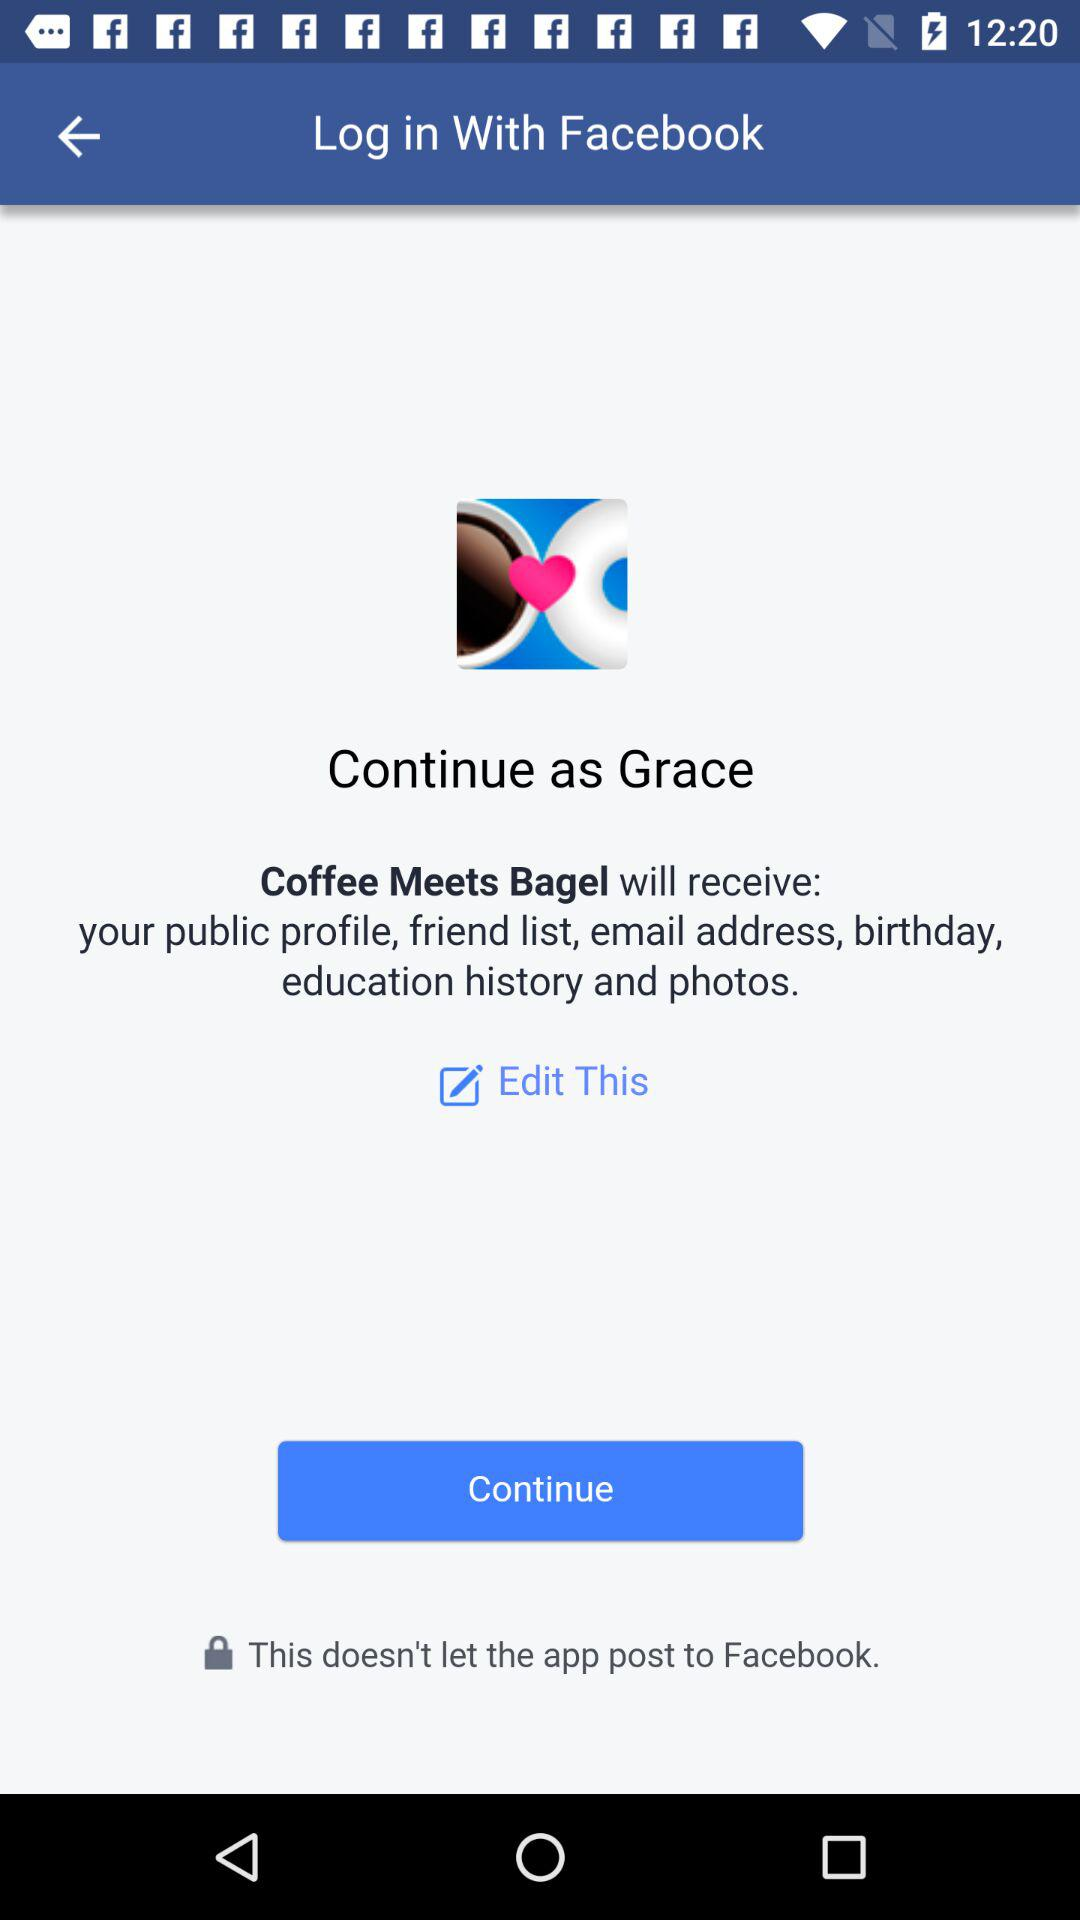Which application is asking for permission? The application is asking for permission is "Coffee Meets Bagel". 